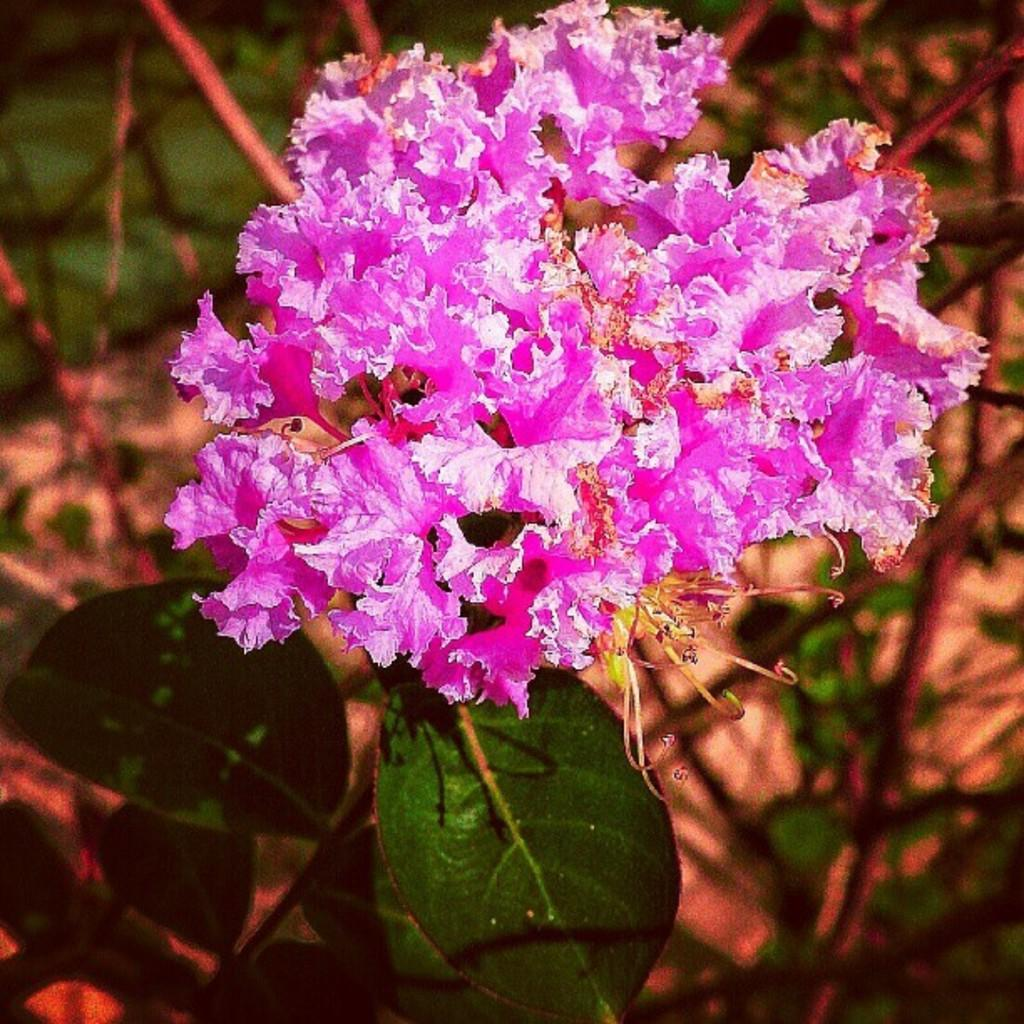What type of plant is visible in the image? There is a plant in the image, and it has a flower and leaves. Can you describe the flower on the plant? The flower on the plant is visible in the image, but no specific details about its appearance are provided. What else can be seen in the image besides the plant? The background of the image is blurred, but no specific objects or features are mentioned. What type of scent can be detected from the plant in the image? There is no information provided about the scent of the plant in the image. 